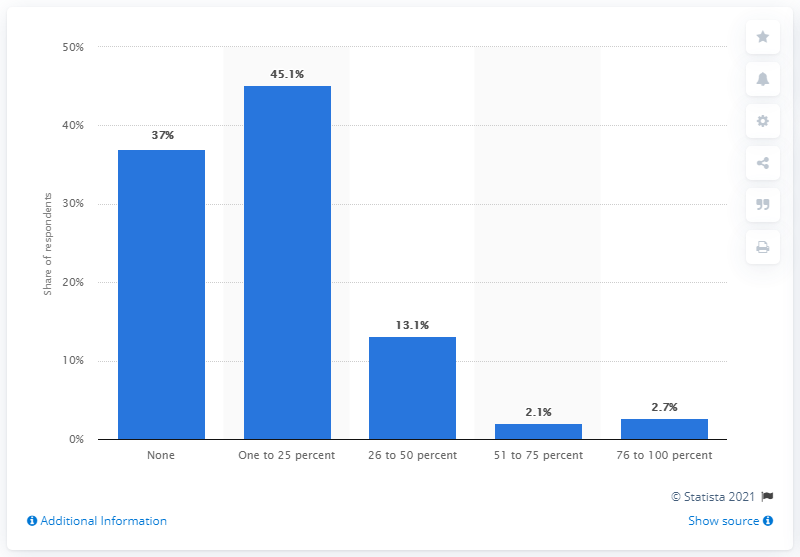Specify some key components in this picture. According to the data, 45.1% of respondents reported that between 1% and 25% of their employees were paid the minimum wage. 